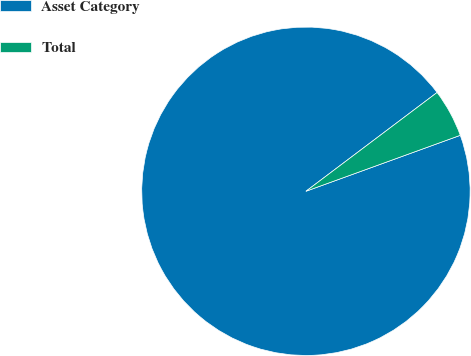Convert chart to OTSL. <chart><loc_0><loc_0><loc_500><loc_500><pie_chart><fcel>Asset Category<fcel>Total<nl><fcel>95.26%<fcel>4.74%<nl></chart> 